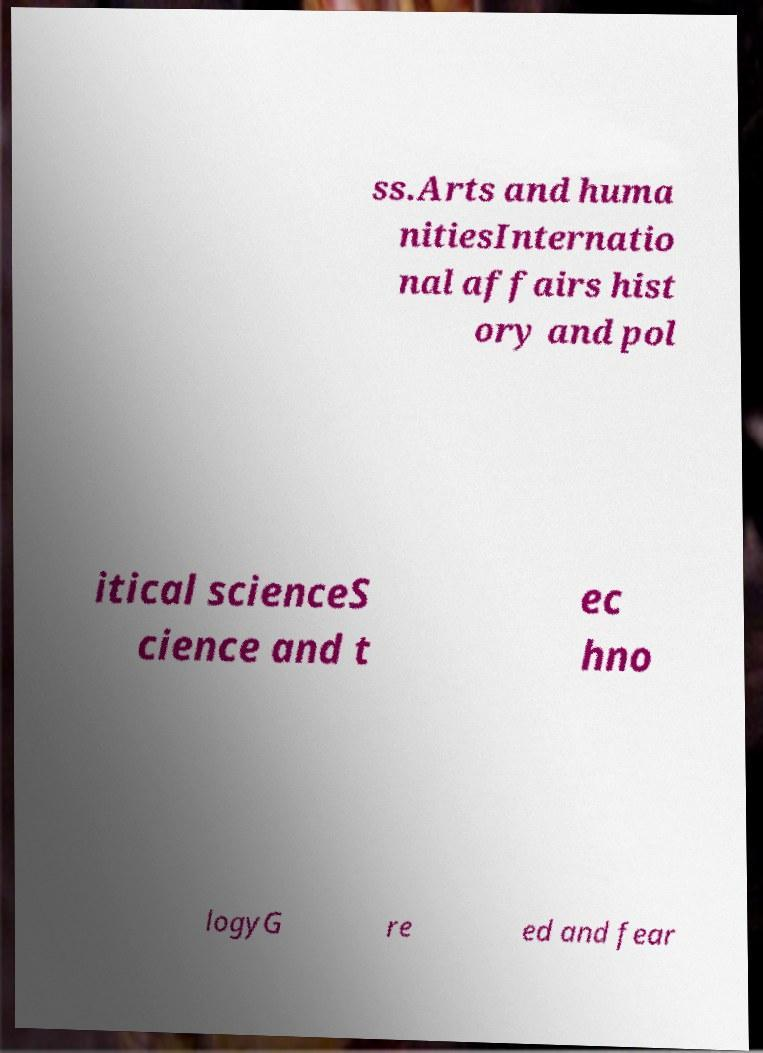Could you extract and type out the text from this image? ss.Arts and huma nitiesInternatio nal affairs hist ory and pol itical scienceS cience and t ec hno logyG re ed and fear 